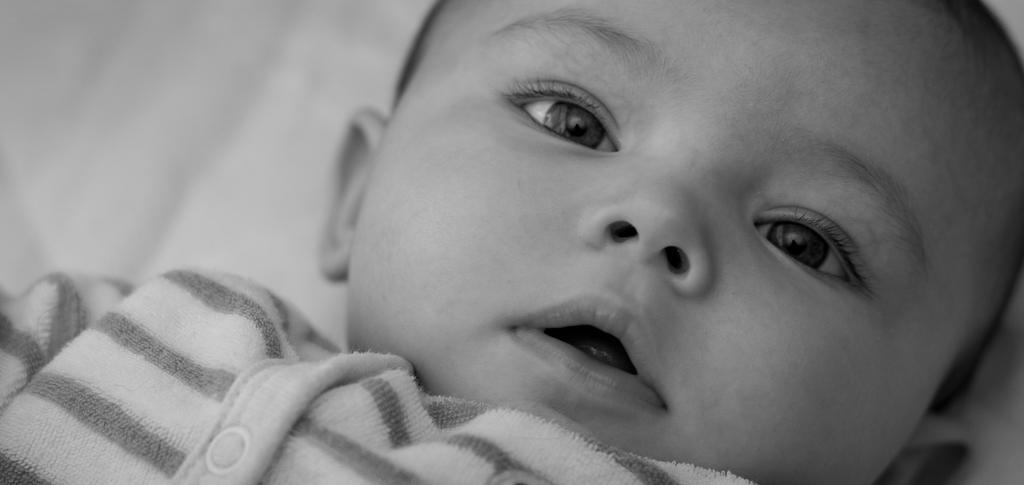How would you summarize this image in a sentence or two? This is a black and white image where we can see a baby. 